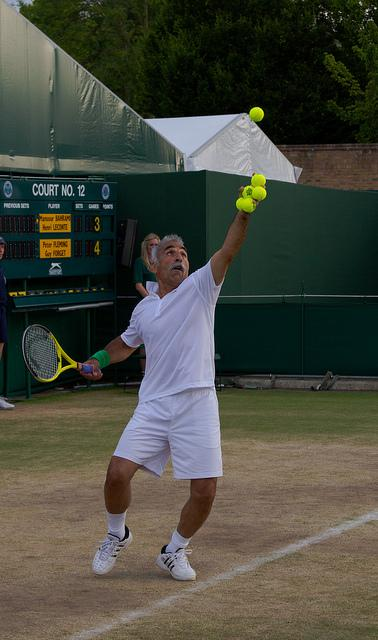Why is he holding several tennis balls? Please explain your reasoning. practicing serve. The man is holding several tennis balls so he can hit them consecutively while practicing his serve. 